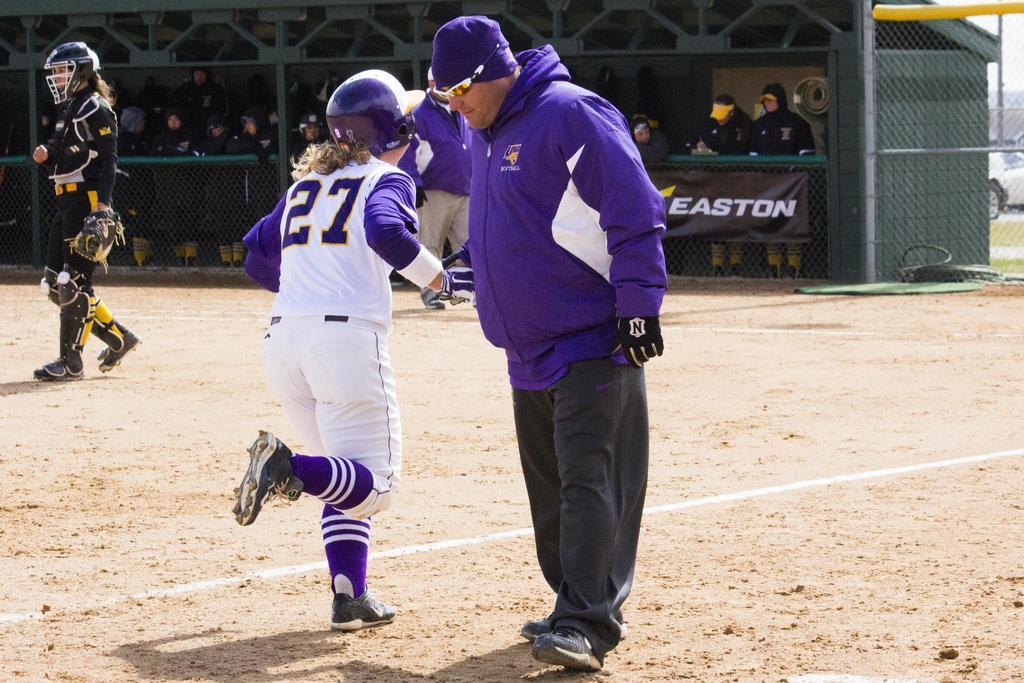What advertisement is being displayed?
Give a very brief answer. Easton. 